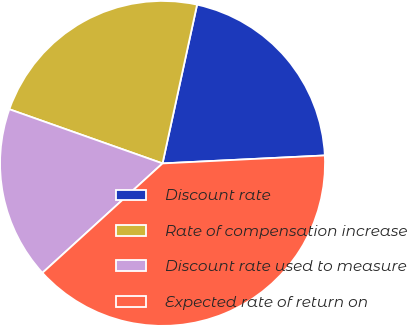Convert chart to OTSL. <chart><loc_0><loc_0><loc_500><loc_500><pie_chart><fcel>Discount rate<fcel>Rate of compensation increase<fcel>Discount rate used to measure<fcel>Expected rate of return on<nl><fcel>20.81%<fcel>23.0%<fcel>17.17%<fcel>39.02%<nl></chart> 